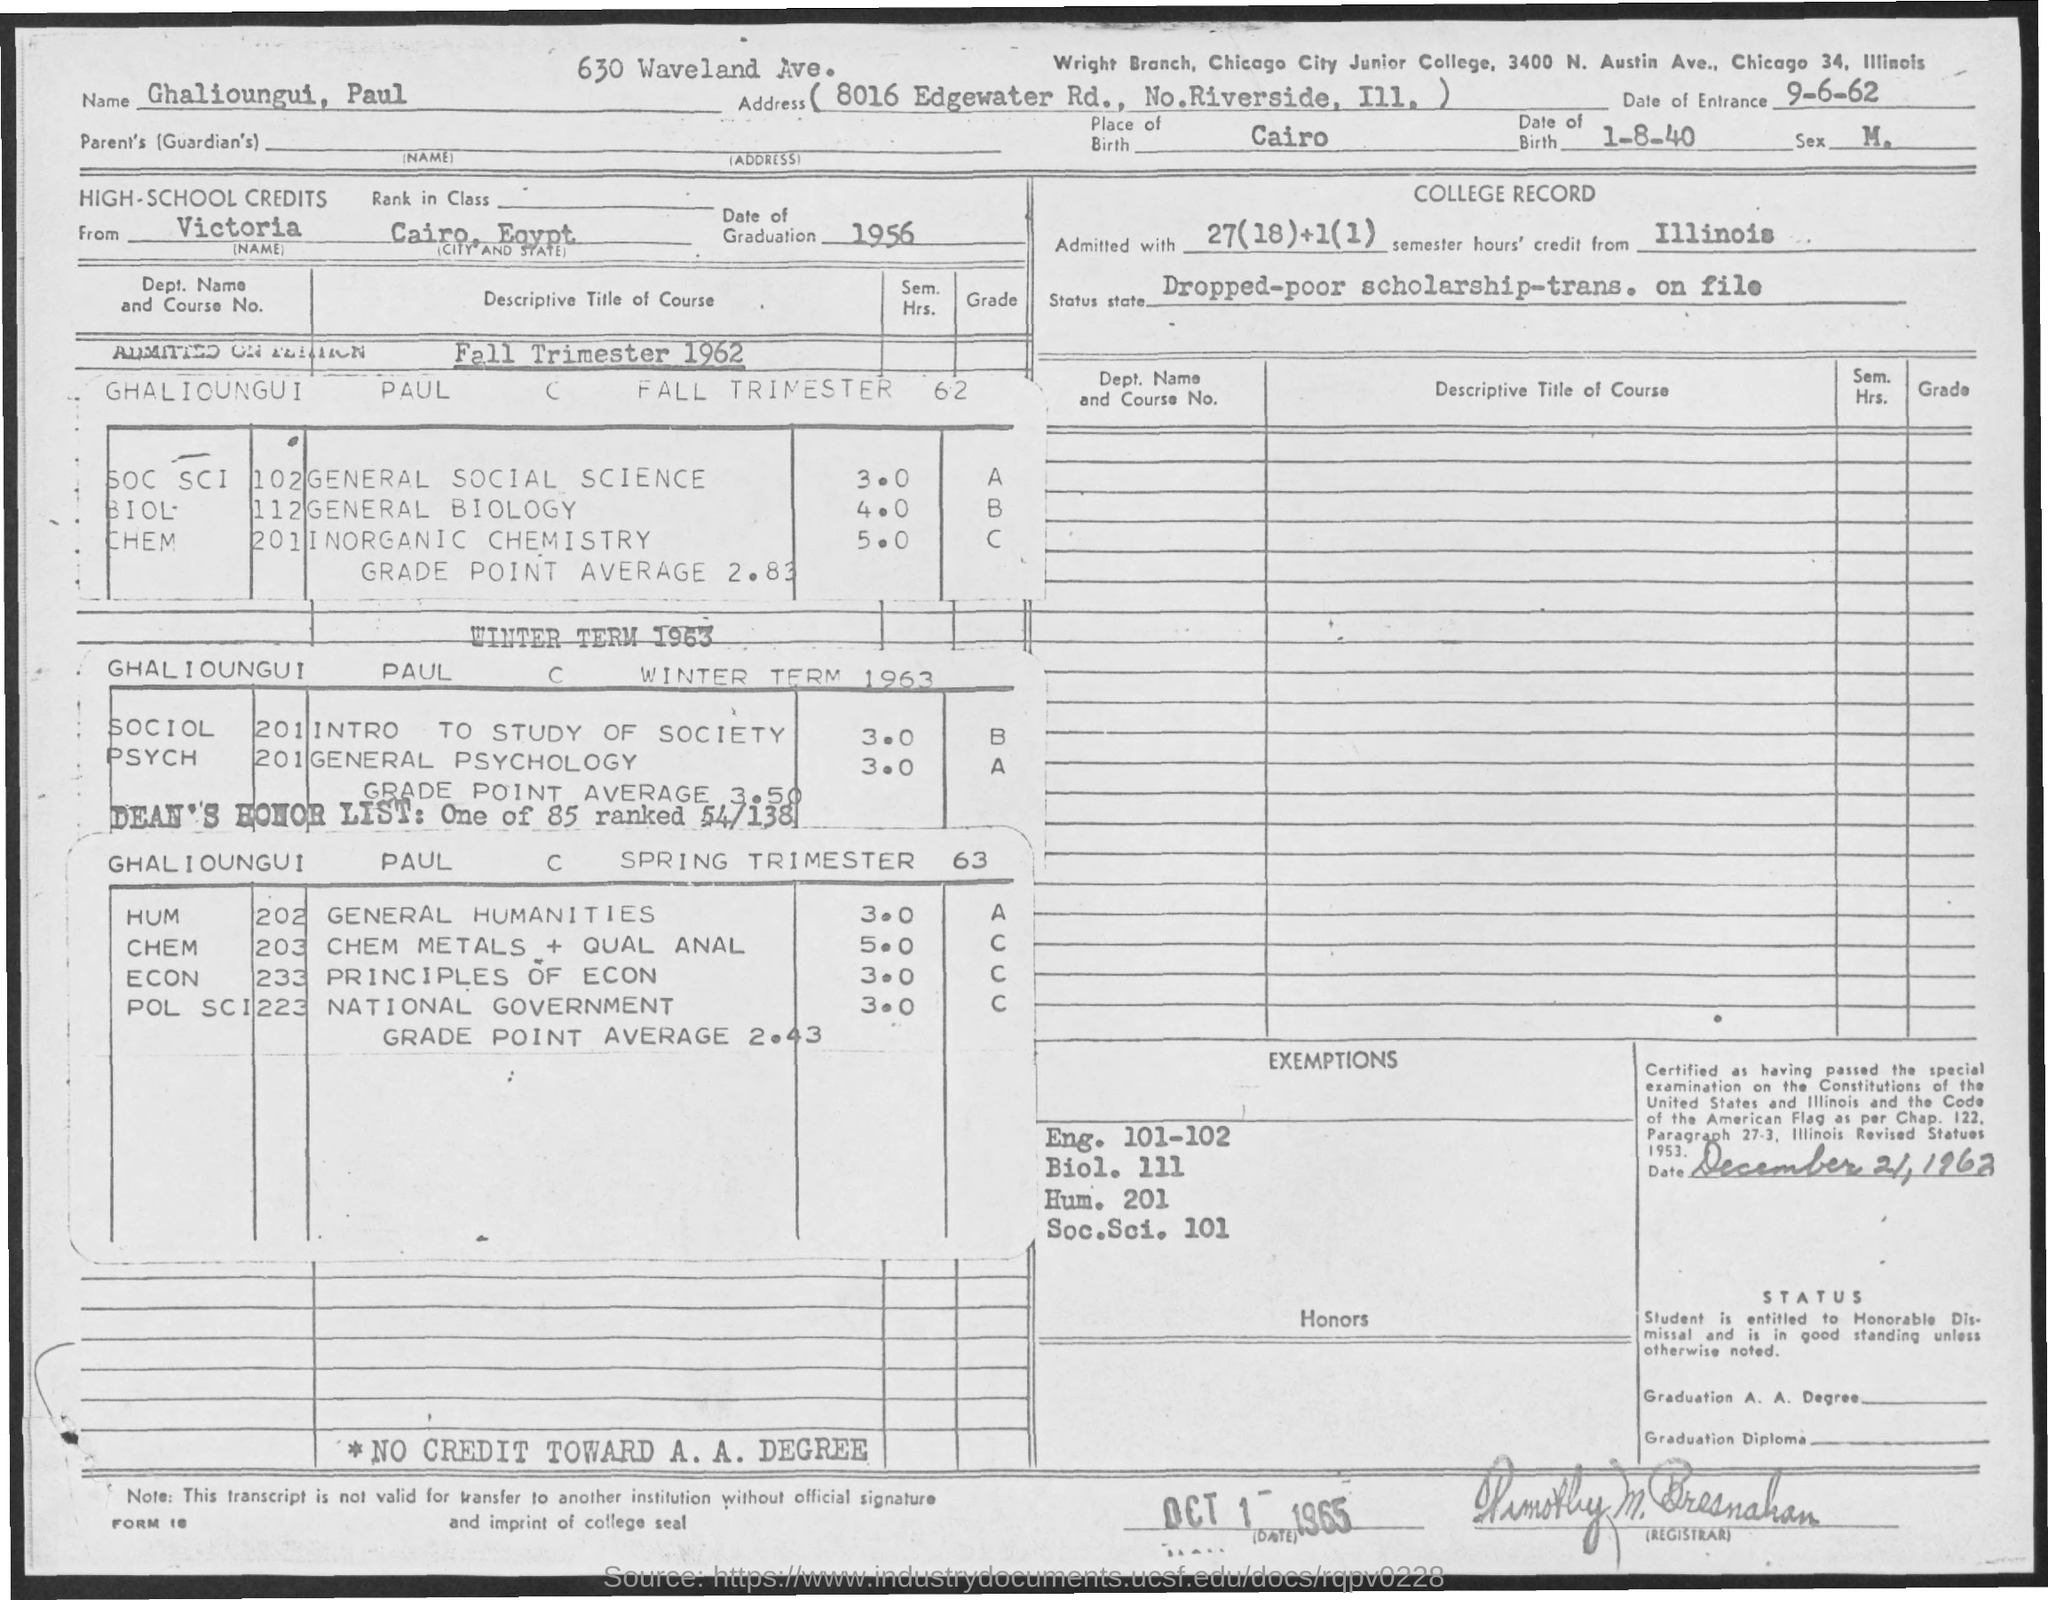Which is the Birthplace of Ghalioungui, Paul?
Your answer should be very brief. Cairo. What is the Date of Birth of Ghalioungui, Paul?
Offer a very short reply. 1-8-40. What is the date of entrance  given in the document?
Provide a succinct answer. 9-6-62. What is the date of graduation of Ghalioungui Paul from high school?
Give a very brief answer. 1956. 